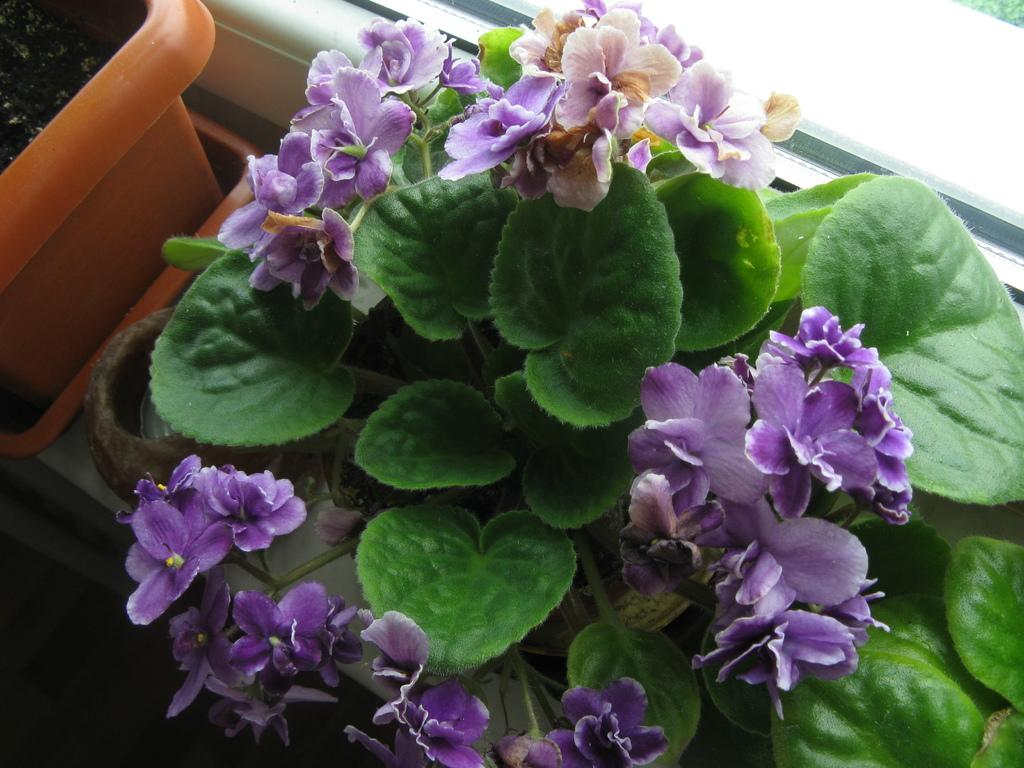What is located at the bottom of the image? There is a plant and some flowers at the bottom of the image. Where is the flower pot situated in the image? The flower pot is in the top left corner of the image. What can be seen at the top of the image? There is a glass window at the top of the image. What type of creature is sitting on the glass window in the image? There is no creature present on the glass window in the image. What kind of insurance policy is mentioned in the image? There is no mention of insurance in the image. 